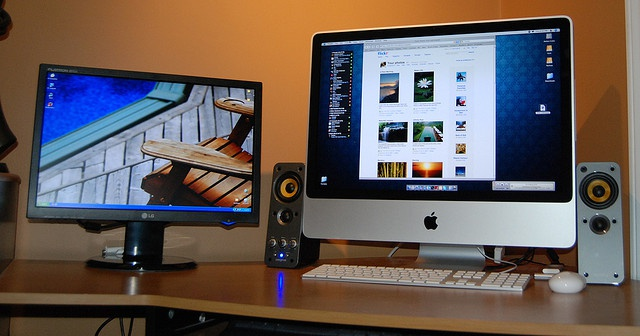Describe the objects in this image and their specific colors. I can see tv in black, lavender, darkgray, and navy tones, tv in black, darkgray, and blue tones, chair in black, darkgray, tan, and gray tones, keyboard in black, darkgray, and gray tones, and mouse in black, darkgray, and gray tones in this image. 